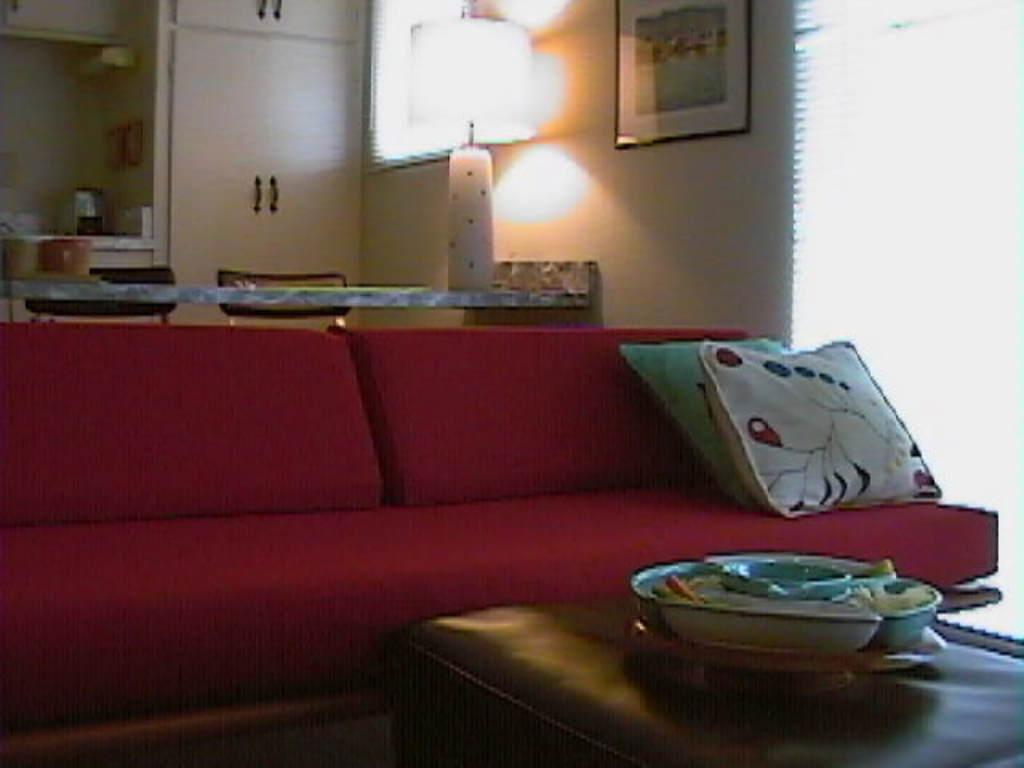What type of room is depicted in the image? There is a living room in the image. What furniture is present in the living room? There is a sofa and a table in the image. What other items can be seen in the living room? Various items are present in the image. What type of trousers is the wall wearing in the image? There are no trousers or walls wearing trousers present in the image. What is the color of the floor in the image? The provided facts do not mention the floor, so we cannot determine its color from the image. 